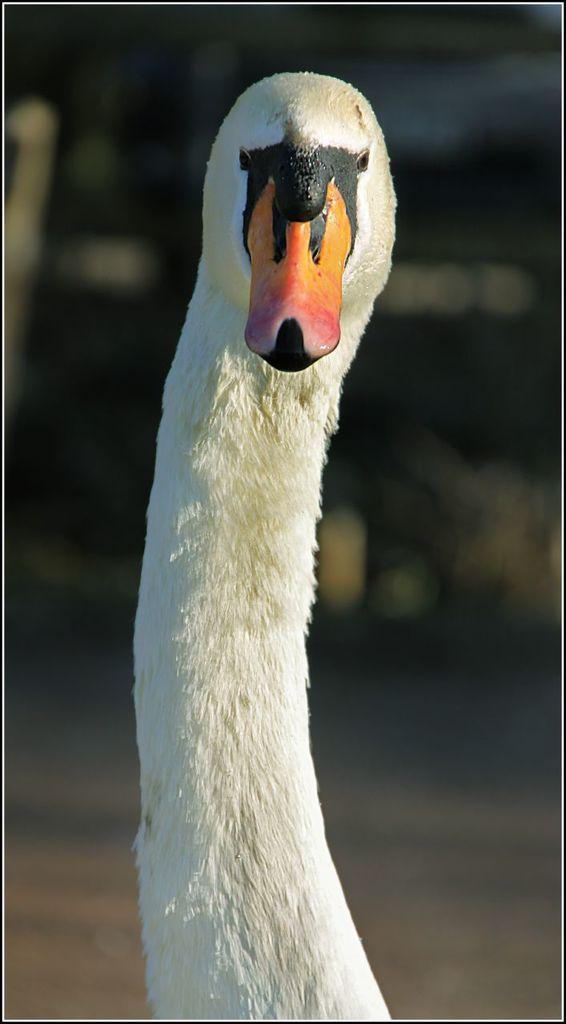What type of animal can be seen in the image? There is a bird in the image. Can you describe the background of the image? The background of the image is blurry. How many alarms are set off by the crow in the image? There is no crow present in the image, and therefore no alarms are set off. 